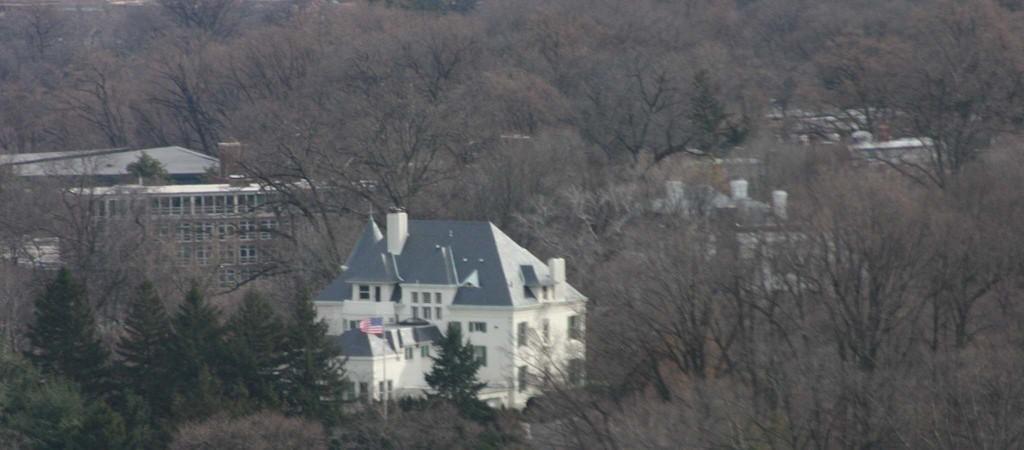Describe this image in one or two sentences. In this image we can see some buildings, windows, a flag, there are some trees. 